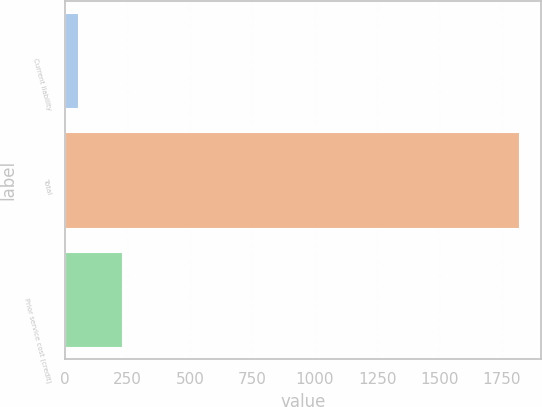Convert chart. <chart><loc_0><loc_0><loc_500><loc_500><bar_chart><fcel>Current liability<fcel>Total<fcel>Prior service cost (credit)<nl><fcel>53<fcel>1817<fcel>229.4<nl></chart> 